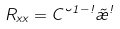<formula> <loc_0><loc_0><loc_500><loc_500>R _ { x x } = C \lambda ^ { 1 - \omega } \tilde { \rho } ^ { \omega }</formula> 